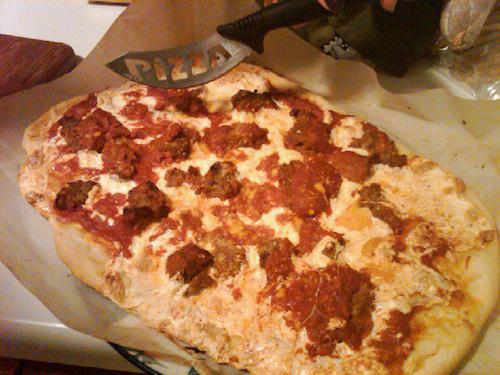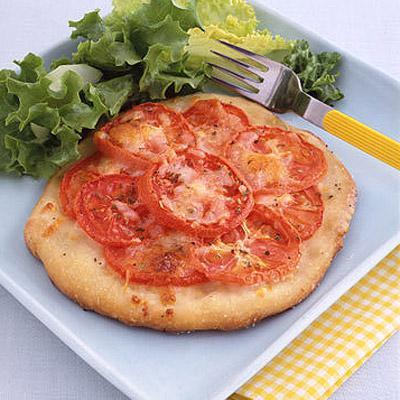The first image is the image on the left, the second image is the image on the right. For the images displayed, is the sentence "The right image shows one slice of a round pizza separated by a small distance from the rest." factually correct? Answer yes or no. No. The first image is the image on the left, the second image is the image on the right. Evaluate the accuracy of this statement regarding the images: "there is a pizza with rounds of mozzarella melted and green bits of basil". Is it true? Answer yes or no. No. 